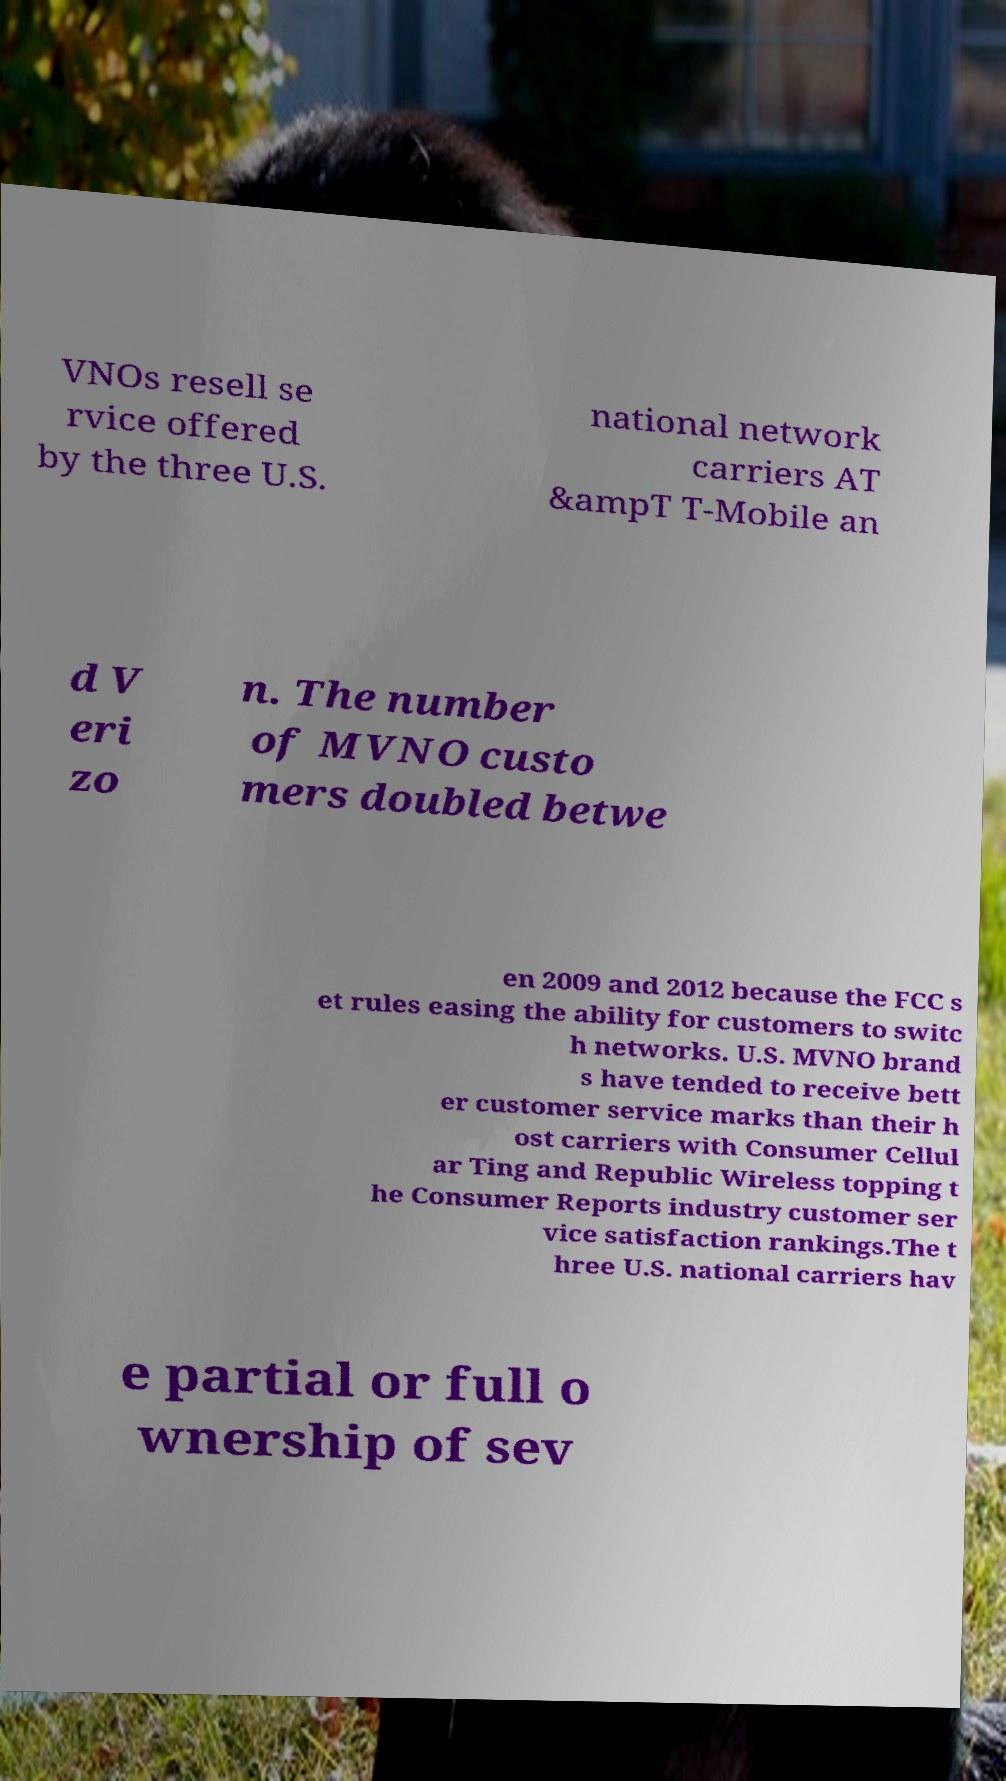Please read and relay the text visible in this image. What does it say? VNOs resell se rvice offered by the three U.S. national network carriers AT &ampT T-Mobile an d V eri zo n. The number of MVNO custo mers doubled betwe en 2009 and 2012 because the FCC s et rules easing the ability for customers to switc h networks. U.S. MVNO brand s have tended to receive bett er customer service marks than their h ost carriers with Consumer Cellul ar Ting and Republic Wireless topping t he Consumer Reports industry customer ser vice satisfaction rankings.The t hree U.S. national carriers hav e partial or full o wnership of sev 